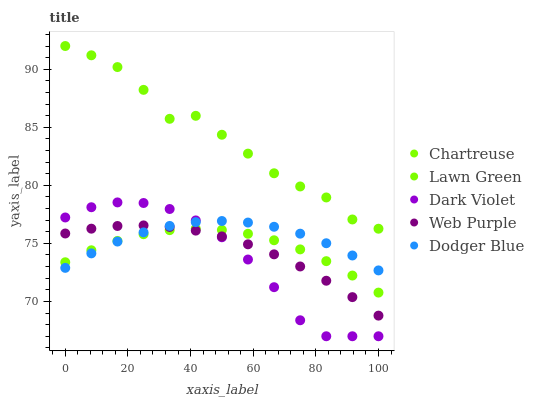Does Dark Violet have the minimum area under the curve?
Answer yes or no. Yes. Does Lawn Green have the maximum area under the curve?
Answer yes or no. Yes. Does Chartreuse have the minimum area under the curve?
Answer yes or no. No. Does Chartreuse have the maximum area under the curve?
Answer yes or no. No. Is Web Purple the smoothest?
Answer yes or no. Yes. Is Lawn Green the roughest?
Answer yes or no. Yes. Is Chartreuse the smoothest?
Answer yes or no. No. Is Chartreuse the roughest?
Answer yes or no. No. Does Dark Violet have the lowest value?
Answer yes or no. Yes. Does Chartreuse have the lowest value?
Answer yes or no. No. Does Lawn Green have the highest value?
Answer yes or no. Yes. Does Dodger Blue have the highest value?
Answer yes or no. No. Is Web Purple less than Lawn Green?
Answer yes or no. Yes. Is Lawn Green greater than Dark Violet?
Answer yes or no. Yes. Does Dark Violet intersect Dodger Blue?
Answer yes or no. Yes. Is Dark Violet less than Dodger Blue?
Answer yes or no. No. Is Dark Violet greater than Dodger Blue?
Answer yes or no. No. Does Web Purple intersect Lawn Green?
Answer yes or no. No. 